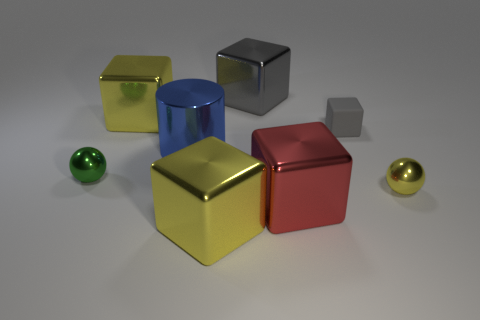Subtract all red blocks. How many blocks are left? 4 Subtract all small gray blocks. How many blocks are left? 4 Subtract all red blocks. Subtract all cyan cylinders. How many blocks are left? 4 Add 2 large yellow things. How many objects exist? 10 Subtract all spheres. How many objects are left? 6 Subtract all tiny cyan shiny spheres. Subtract all red metal cubes. How many objects are left? 7 Add 2 big gray shiny blocks. How many big gray shiny blocks are left? 3 Add 4 large gray cubes. How many large gray cubes exist? 5 Subtract 1 red cubes. How many objects are left? 7 